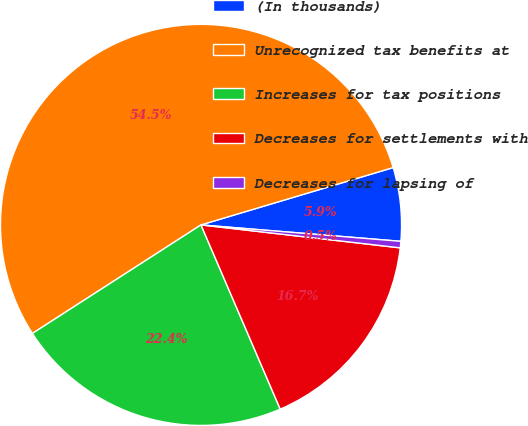Convert chart. <chart><loc_0><loc_0><loc_500><loc_500><pie_chart><fcel>(In thousands)<fcel>Unrecognized tax benefits at<fcel>Increases for tax positions<fcel>Decreases for settlements with<fcel>Decreases for lapsing of<nl><fcel>5.92%<fcel>54.49%<fcel>22.36%<fcel>16.71%<fcel>0.52%<nl></chart> 